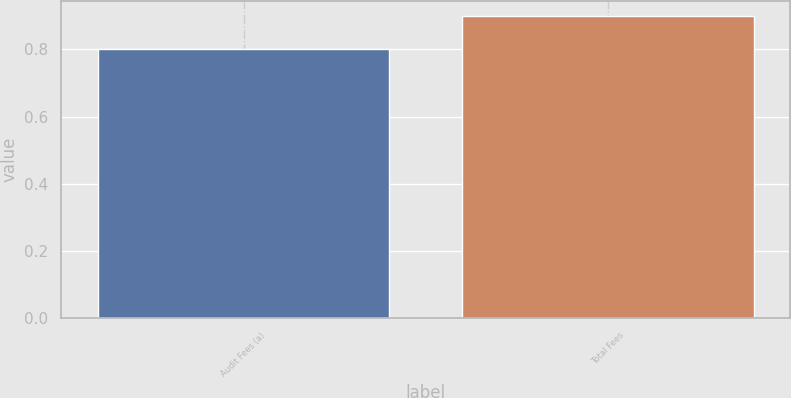Convert chart to OTSL. <chart><loc_0><loc_0><loc_500><loc_500><bar_chart><fcel>Audit Fees (a)<fcel>Total Fees<nl><fcel>0.8<fcel>0.9<nl></chart> 